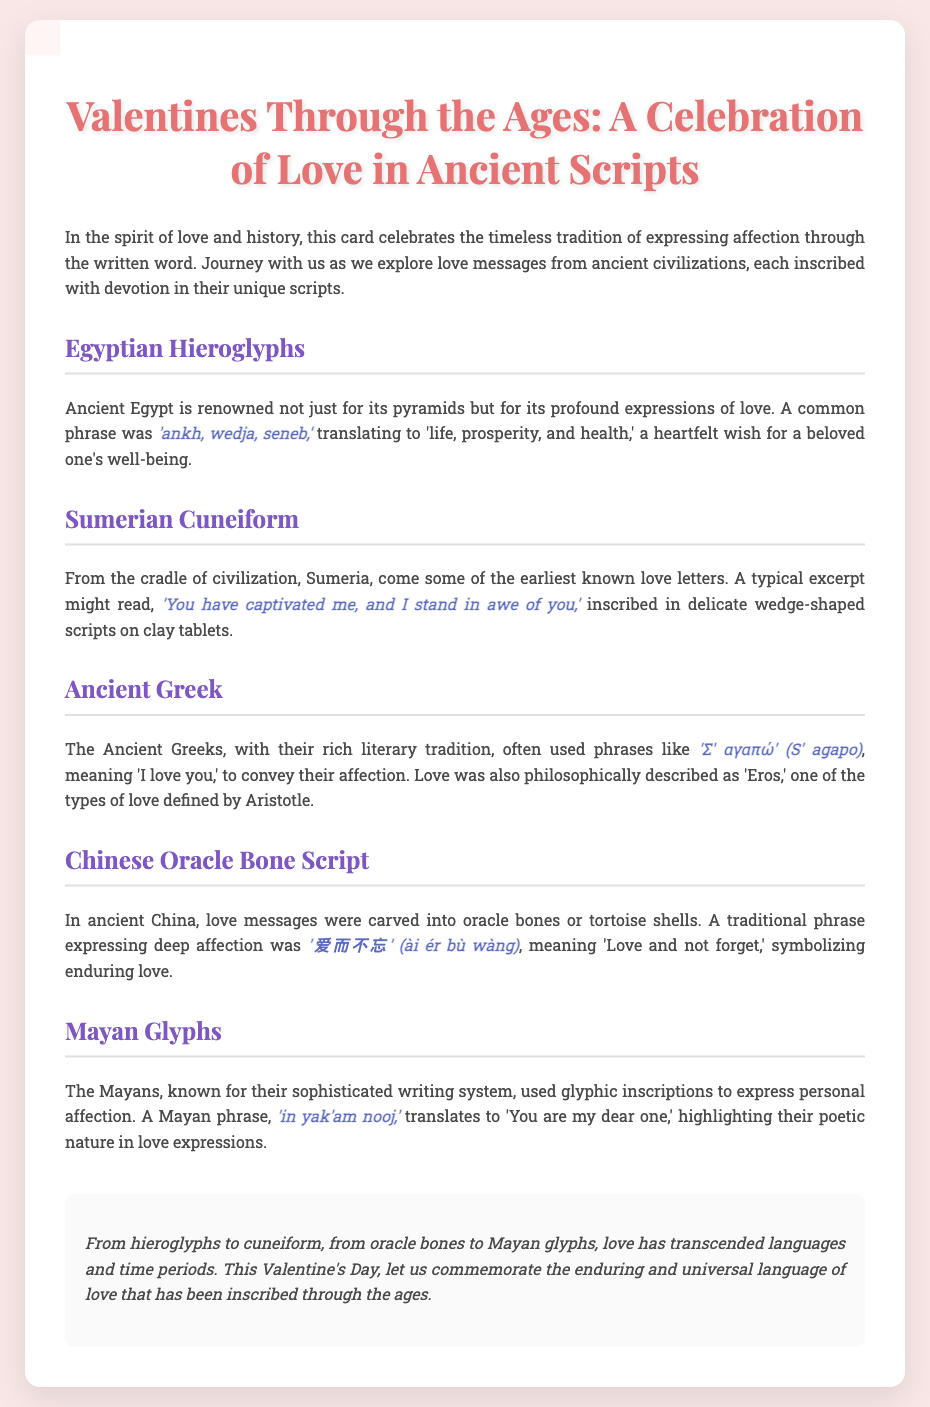What is the title of the card? The title is prominently displayed at the top of the card and reads "Valentines Through the Ages: A Celebration of Love in Ancient Scripts."
Answer: Valentines Through the Ages: A Celebration of Love in Ancient Scripts Which ancient civilization's love message includes the phrase 'ankh, wedja, seneb'? This phrase is associated with Ancient Egypt, as stated in the section about Egyptian Hieroglyphs.
Answer: Ancient Egypt What does the Sumerian phrase 'You have captivated me, and I stand in awe of you' express? This phrase reflects admiration and affection, showcased in the context of Sumerian love letters.
Answer: Admiration and affection What is the meaning of '爱而不忘' in the Chinese Oracle Bone Script section? The meaning of this phrase is explained in relation to enduring love, as highlighted in the Chinese Oracle Bone Script section.
Answer: Love and not forget How many ancient scripts are mentioned in the card? The card outlines five distinct ancient scripts as part of its exploration of love messages.
Answer: Five What type of writing system did the Mayans use? The card specifies that the Mayans used glyphic inscriptions to convey personal affection.
Answer: Glyphic inscriptions What does the Greek phrase 'Σ' αγαπώ' (S' agapo) mean? The document explicitly states that this phrase means 'I love you,' indicating its context in expressing affection.
Answer: I love you What cultural significance do the examples of love messages have in the card? The card highlights that they showcase the timeless tradition of expressing affection through the written word across various cultures.
Answer: Timeless tradition of expressing affection 